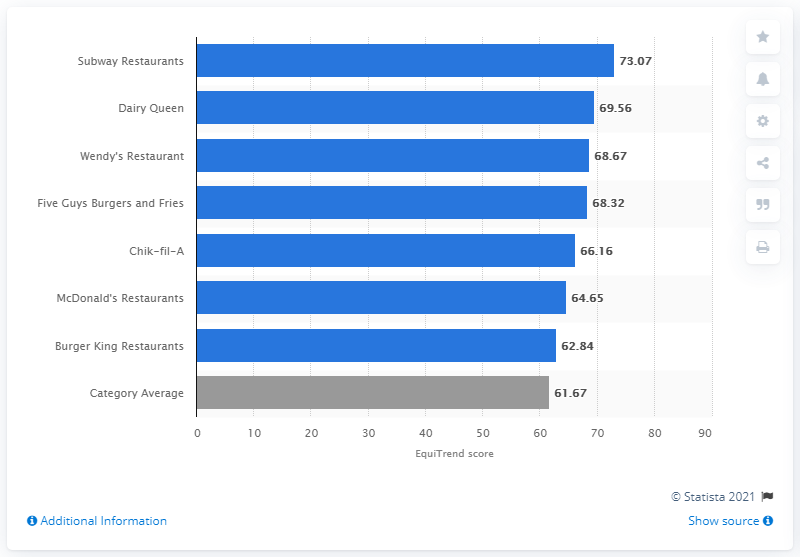Specify some key components in this picture. In 2012, Subway Restaurants received an EquiTrend score of 73.07, indicating high customer satisfaction and positive brand perception. 